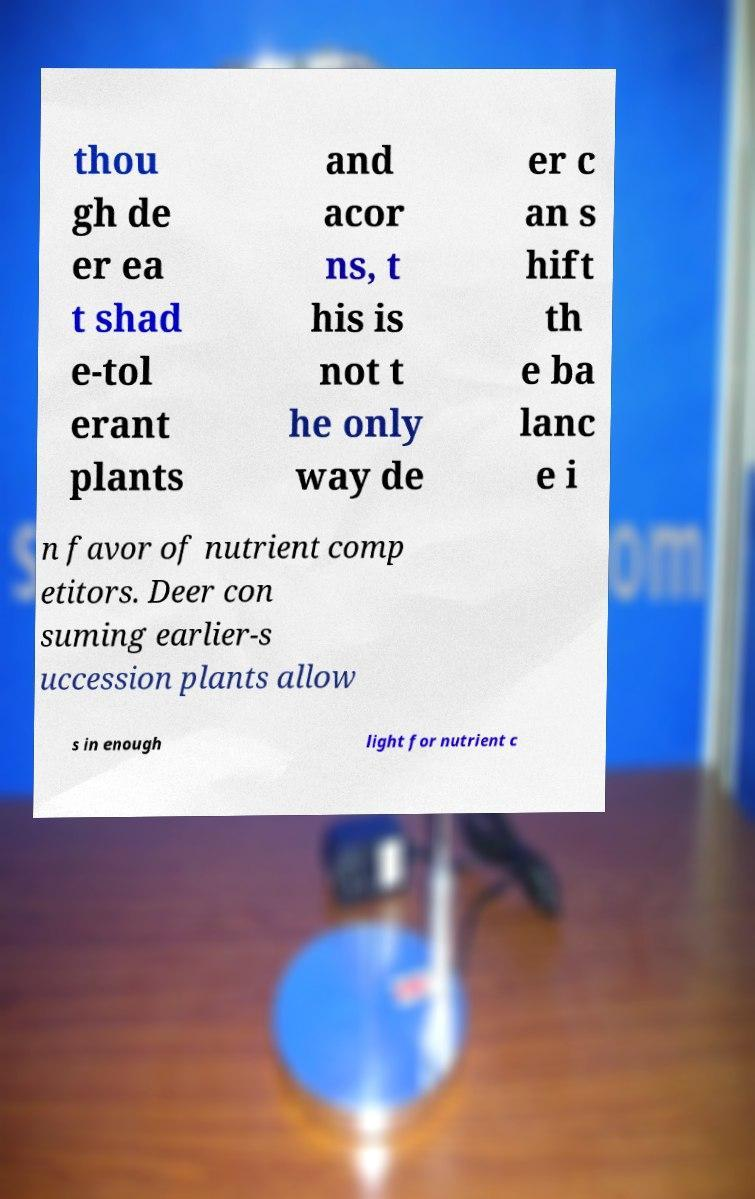Could you extract and type out the text from this image? thou gh de er ea t shad e-tol erant plants and acor ns, t his is not t he only way de er c an s hift th e ba lanc e i n favor of nutrient comp etitors. Deer con suming earlier-s uccession plants allow s in enough light for nutrient c 